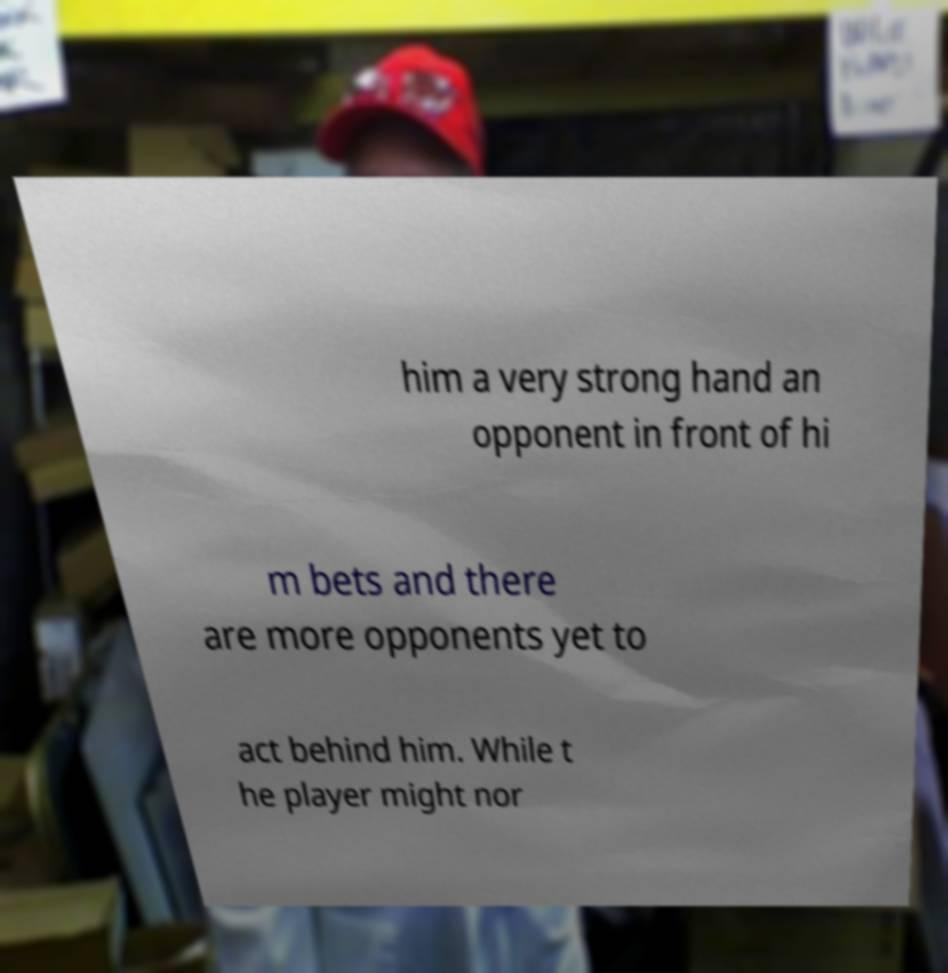For documentation purposes, I need the text within this image transcribed. Could you provide that? him a very strong hand an opponent in front of hi m bets and there are more opponents yet to act behind him. While t he player might nor 